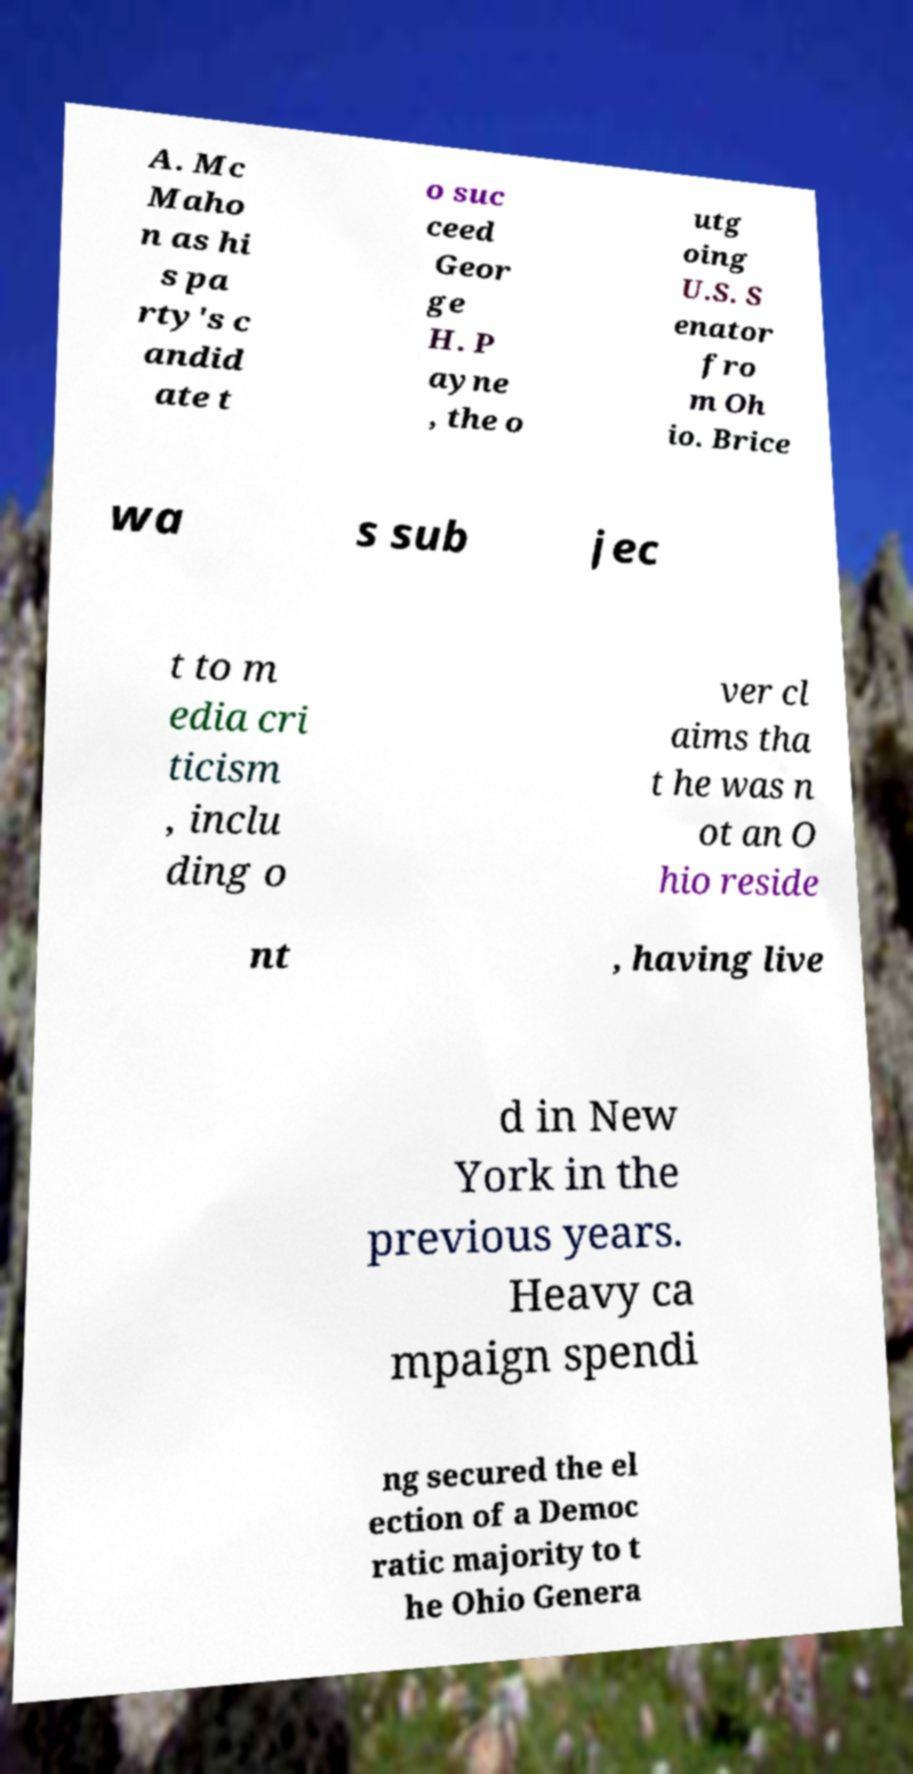Could you extract and type out the text from this image? A. Mc Maho n as hi s pa rty's c andid ate t o suc ceed Geor ge H. P ayne , the o utg oing U.S. S enator fro m Oh io. Brice wa s sub jec t to m edia cri ticism , inclu ding o ver cl aims tha t he was n ot an O hio reside nt , having live d in New York in the previous years. Heavy ca mpaign spendi ng secured the el ection of a Democ ratic majority to t he Ohio Genera 